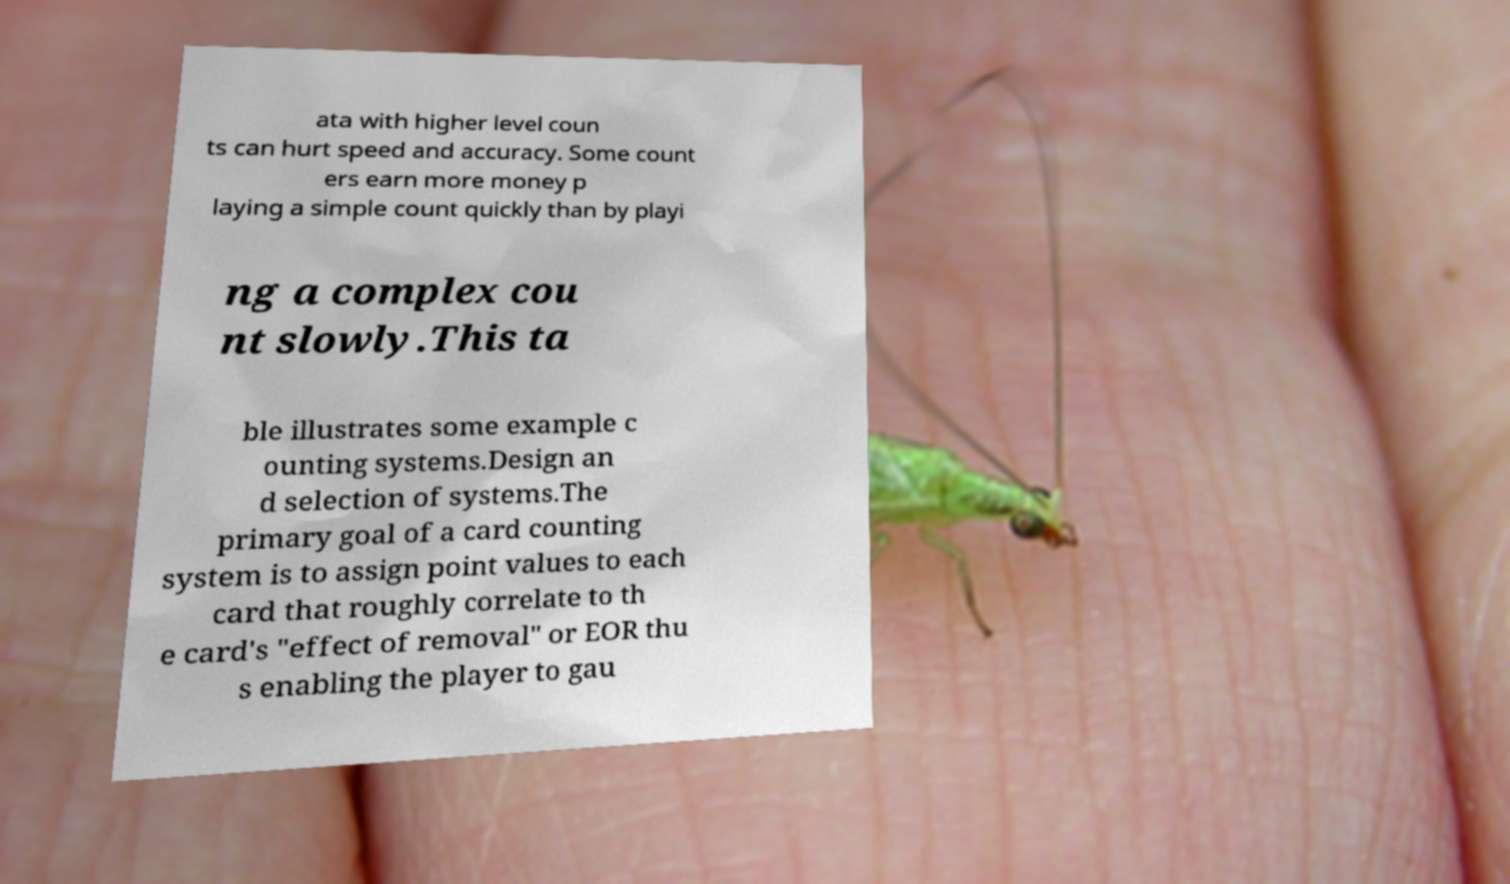For documentation purposes, I need the text within this image transcribed. Could you provide that? ata with higher level coun ts can hurt speed and accuracy. Some count ers earn more money p laying a simple count quickly than by playi ng a complex cou nt slowly.This ta ble illustrates some example c ounting systems.Design an d selection of systems.The primary goal of a card counting system is to assign point values to each card that roughly correlate to th e card's "effect of removal" or EOR thu s enabling the player to gau 